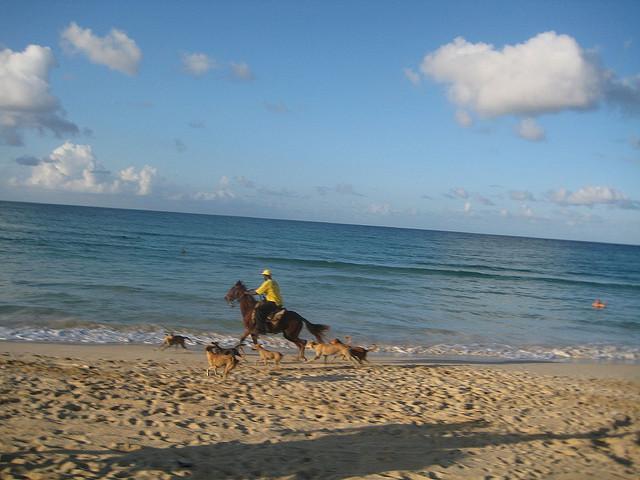Could that be a moon?
Short answer required. No. Are the horses running?
Write a very short answer. Yes. Does the man have a small army of dogs?
Give a very brief answer. Yes. What type of animals are in the water?
Short answer required. Dogs. Does the person have a good relationship with these dogs?
Write a very short answer. Yes. What is the guy riding?
Be succinct. Horse. 